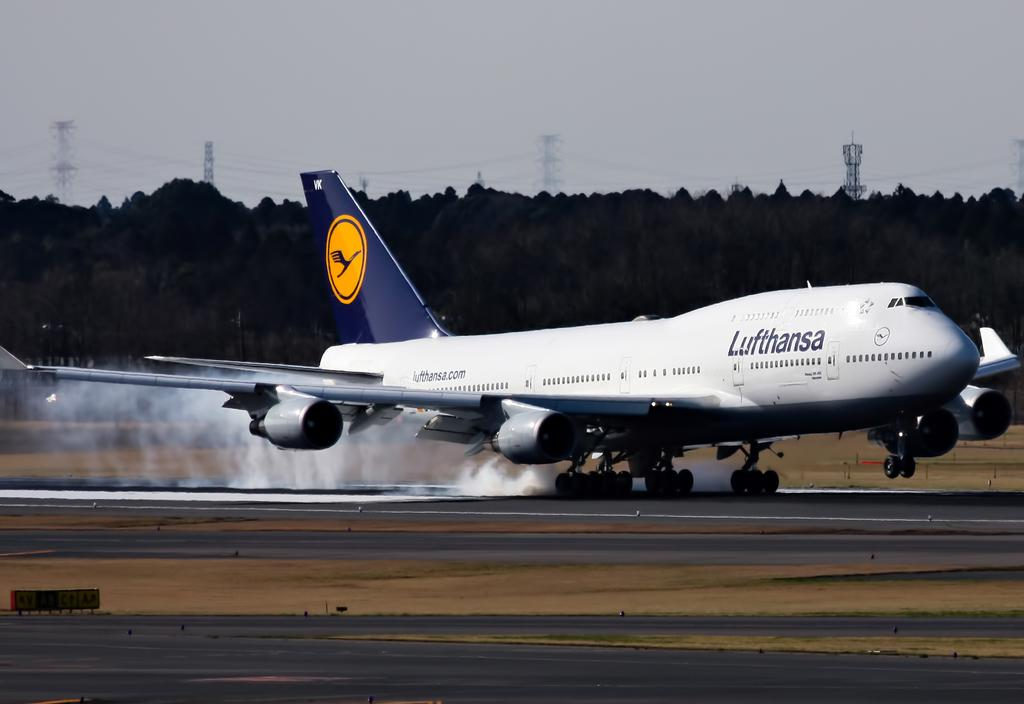<image>
Present a compact description of the photo's key features. Lufthansa white and blue airplane is on ground about to take off 